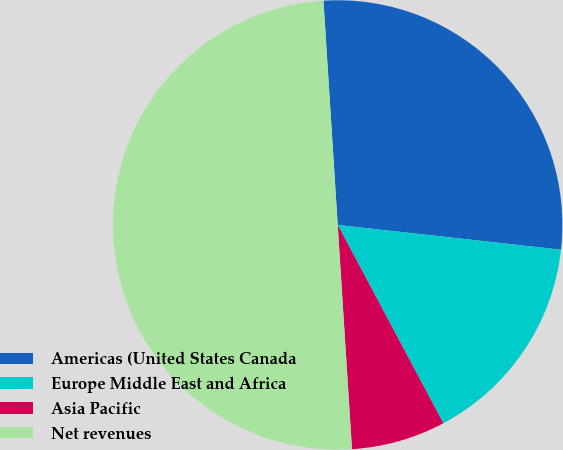Convert chart. <chart><loc_0><loc_0><loc_500><loc_500><pie_chart><fcel>Americas (United States Canada<fcel>Europe Middle East and Africa<fcel>Asia Pacific<fcel>Net revenues<nl><fcel>27.77%<fcel>15.45%<fcel>6.78%<fcel>50.0%<nl></chart> 